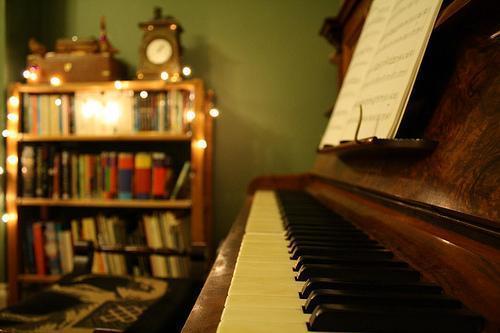How many people are in the picture?
Give a very brief answer. 0. 